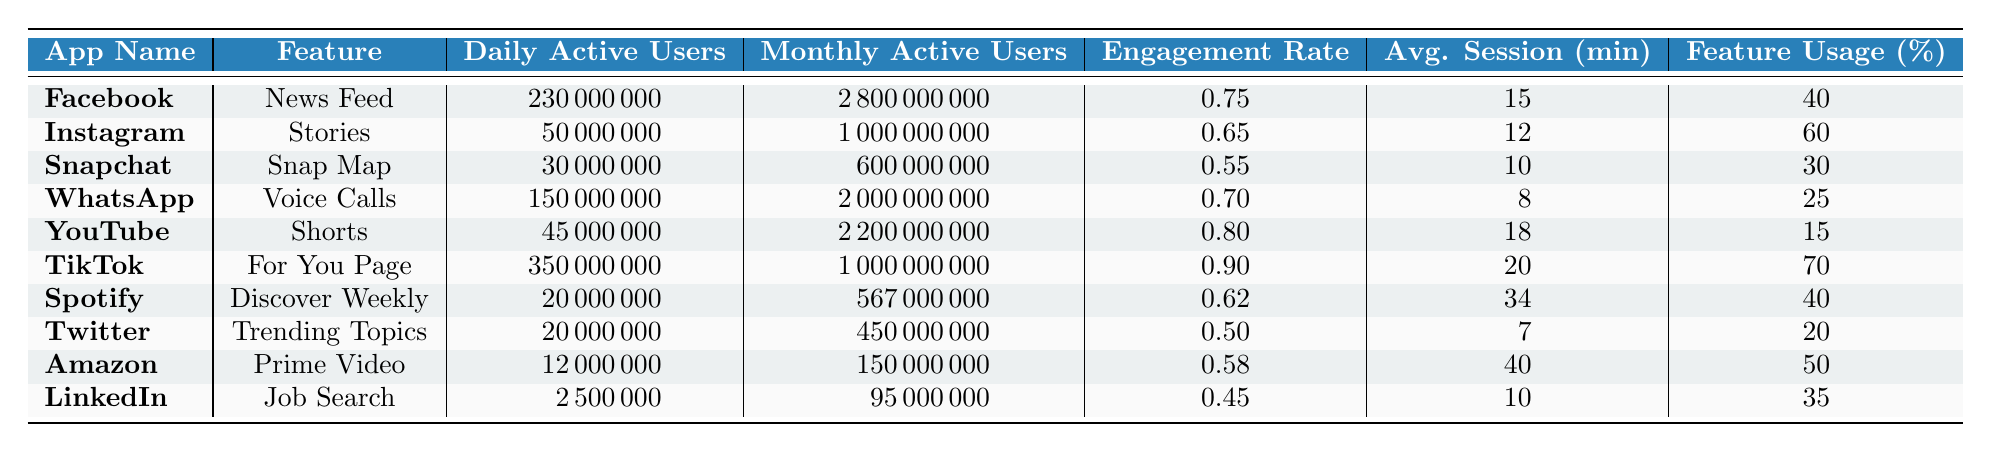What is the Daily Active Users count for TikTok? The table lists TikTok's Daily Active Users under the "Daily Active Users" column. The specific value provided is 350,000,000.
Answer: 350000000 Which app has the highest Engagement Rate? By comparing the Engagement Rate column for each app, TikTok shows the highest value of 0.90.
Answer: TikTok What is the Average Session Duration for Amazon? The table shows Amazon's Average Session Duration as noted in the corresponding column which states 40 minutes.
Answer: 40 Which apps have a Feature Usage Percentage greater than 50%? Looking through the table, Instagram (60%) and TikTok (70%) are the only apps with a Feature Usage Percentage greater than 50%.
Answer: Instagram, TikTok What is the total number of Daily Active Users for Instagram and WhatsApp combined? Adding the Daily Active Users for Instagram (50,000,000) and WhatsApp (150,000,000), we obtain 50,000,000 + 150,000,000 = 200,000,000.
Answer: 200000000 Is the Average Session Duration for YouTube greater than that of Snapchat? The Average Session Duration for YouTube is 18 minutes and for Snapchat it is 10 minutes, thus 18 > 10 is true.
Answer: Yes Which app has the lowest Monthly Active Users? The Monthly Active Users column indicates that LinkedIn has the lowest value with 95,000,000.
Answer: LinkedIn What is the average Engagement Rate of the apps listed in the table? The Engagement Rates for all apps are: 0.75, 0.65, 0.55, 0.70, 0.80, 0.90, 0.62, 0.50, 0.58, 0.45. Summing these gives 0.75 + 0.65 + 0.55 + 0.70 + 0.80 + 0.90 + 0.62 + 0.50 + 0.58 + 0.45 = 6.70. Dividing by the number of apps (10) yields an average of 6.70 / 10 = 0.67.
Answer: 0.67 How many Daily Active Users does Spotify have compared to Facebook? Comparing the values, Spotify has 20,000,000 Daily Active Users while Facebook has 230,000,000. Thus, 20,000,000 is significantly less than 230,000,000.
Answer: Less Which app has both a higher Daily Active User count and Engagement Rate than LinkedIn? LinkedIn has 2,500,000 Daily Active Users and an Engagement Rate of 0.45. Observing the table, TikTok (350,000,000 DAUs, 0.90 ER), Instagram (50,000,000 DAUs, 0.65 ER), and YouTube (45,000,000 DAUs, 0.80 ER) all have higher values in both categories.
Answer: TikTok, Instagram, YouTube 